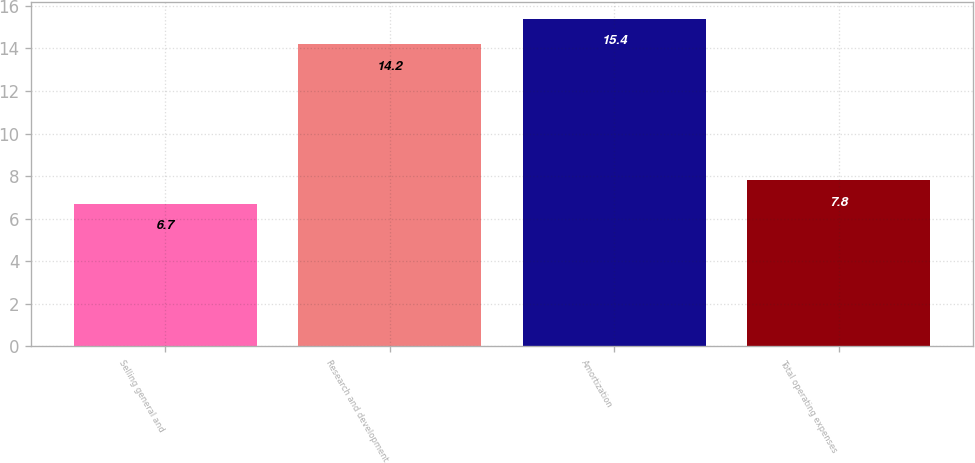Convert chart. <chart><loc_0><loc_0><loc_500><loc_500><bar_chart><fcel>Selling general and<fcel>Research and development<fcel>Amortization<fcel>Total operating expenses<nl><fcel>6.7<fcel>14.2<fcel>15.4<fcel>7.8<nl></chart> 